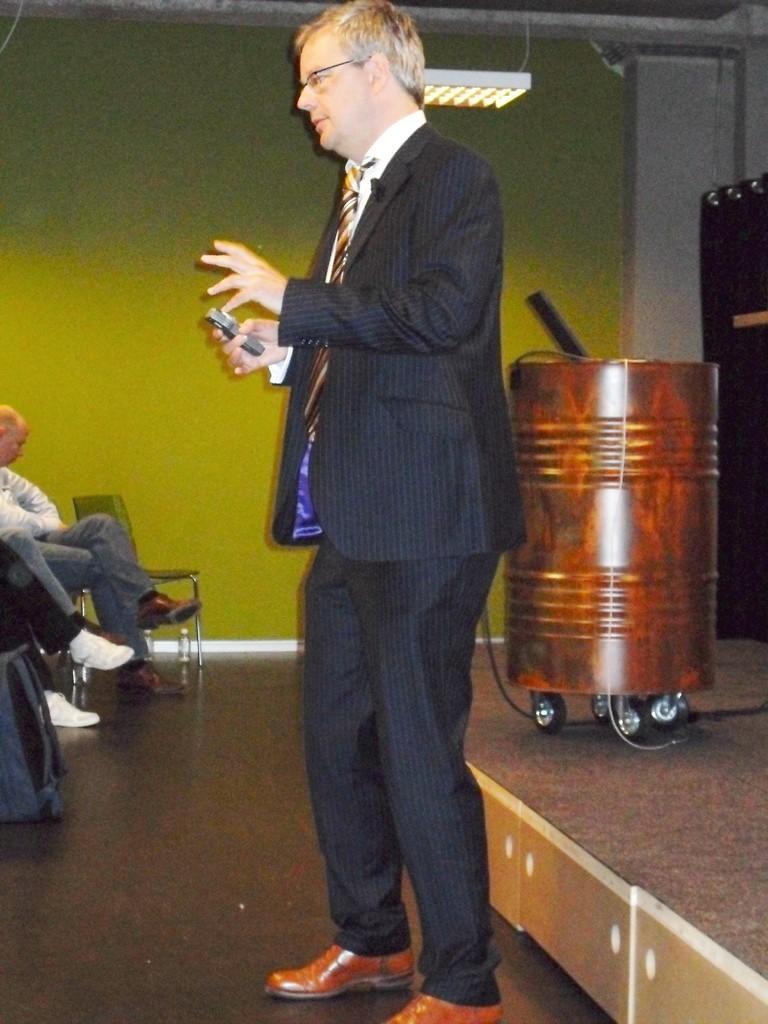Could you give a brief overview of what you see in this image? In this image I can see the person with the dress. To the right I can see the metal object with wheels. To the left I can see few people sitting on the chairs. In the background I can see the green color wall and there is an object. I can see the light at the top. 